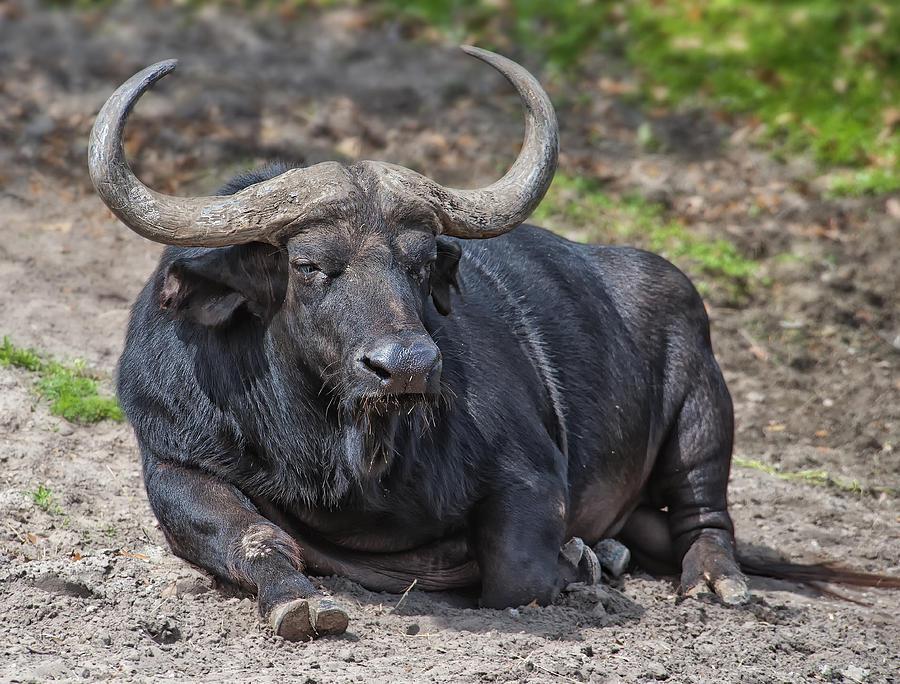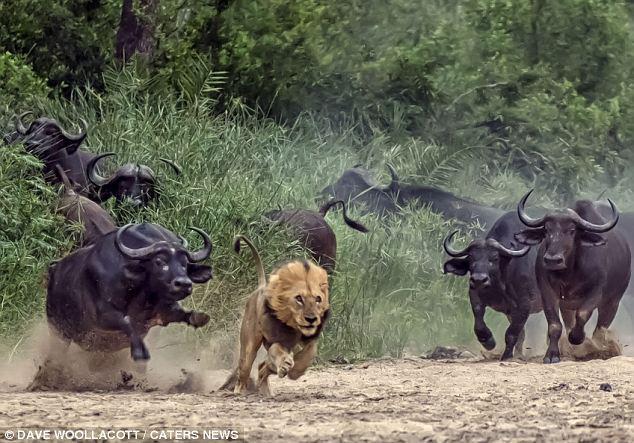The first image is the image on the left, the second image is the image on the right. Considering the images on both sides, is "The animals in the left photo are standing in water." valid? Answer yes or no. No. The first image is the image on the left, the second image is the image on the right. For the images displayed, is the sentence "Left image shows water buffalo standing in wet area." factually correct? Answer yes or no. No. 